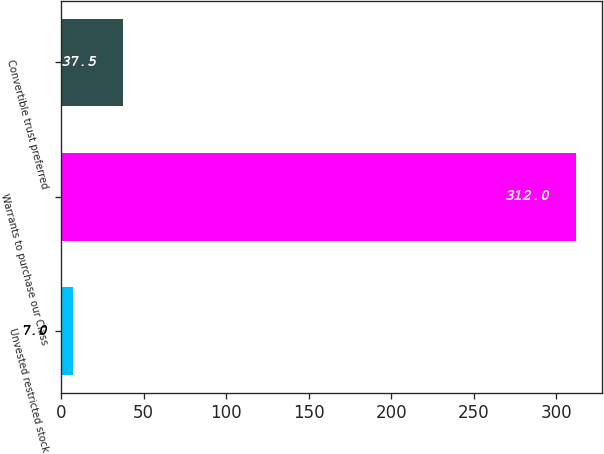<chart> <loc_0><loc_0><loc_500><loc_500><bar_chart><fcel>Unvested restricted stock<fcel>Warrants to purchase our Class<fcel>Convertible trust preferred<nl><fcel>7<fcel>312<fcel>37.5<nl></chart> 